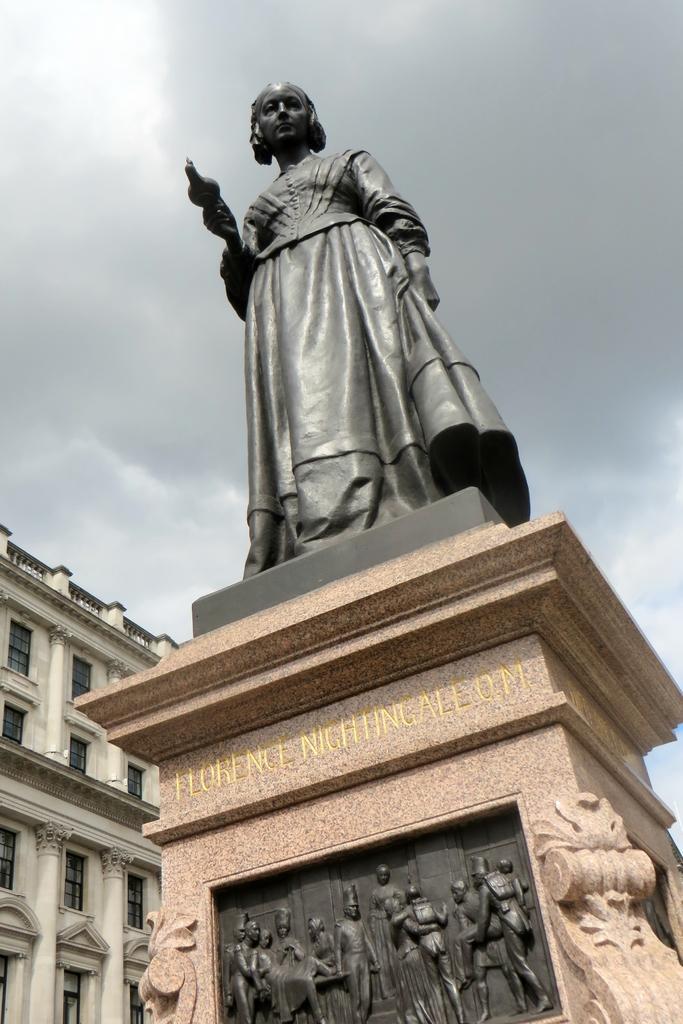Can you describe this image briefly? In the center of the image, we can see a statue and there are some sculptures and there is some text on it. In the background, there is a building and there is sky. 